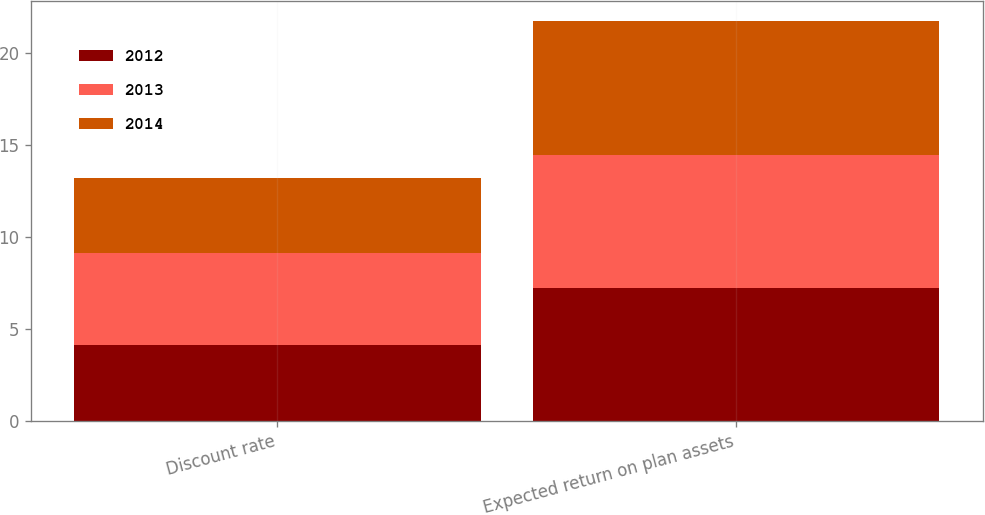Convert chart. <chart><loc_0><loc_0><loc_500><loc_500><stacked_bar_chart><ecel><fcel>Discount rate<fcel>Expected return on plan assets<nl><fcel>2012<fcel>4.15<fcel>7.25<nl><fcel>2013<fcel>5<fcel>7.25<nl><fcel>2014<fcel>4.1<fcel>7.25<nl></chart> 